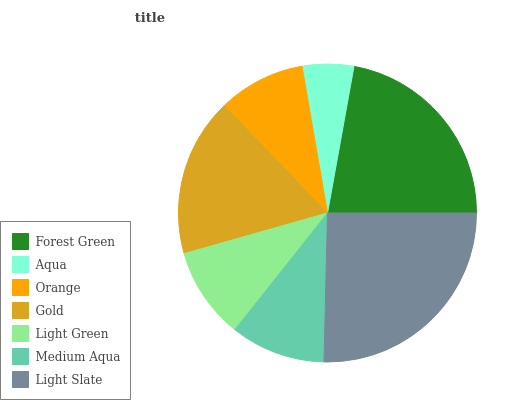Is Aqua the minimum?
Answer yes or no. Yes. Is Light Slate the maximum?
Answer yes or no. Yes. Is Orange the minimum?
Answer yes or no. No. Is Orange the maximum?
Answer yes or no. No. Is Orange greater than Aqua?
Answer yes or no. Yes. Is Aqua less than Orange?
Answer yes or no. Yes. Is Aqua greater than Orange?
Answer yes or no. No. Is Orange less than Aqua?
Answer yes or no. No. Is Medium Aqua the high median?
Answer yes or no. Yes. Is Medium Aqua the low median?
Answer yes or no. Yes. Is Forest Green the high median?
Answer yes or no. No. Is Orange the low median?
Answer yes or no. No. 